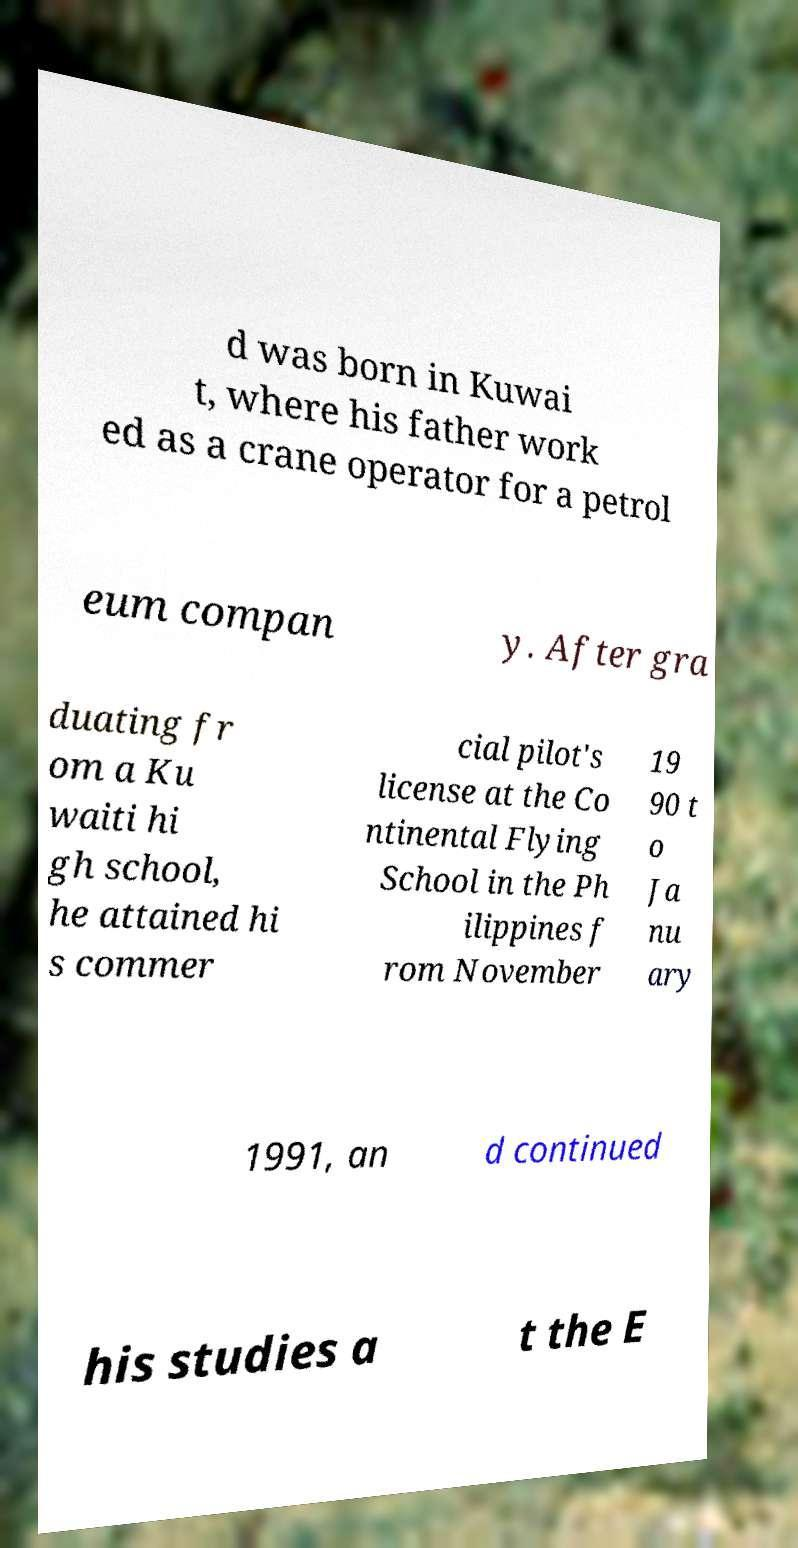What messages or text are displayed in this image? I need them in a readable, typed format. d was born in Kuwai t, where his father work ed as a crane operator for a petrol eum compan y. After gra duating fr om a Ku waiti hi gh school, he attained hi s commer cial pilot's license at the Co ntinental Flying School in the Ph ilippines f rom November 19 90 t o Ja nu ary 1991, an d continued his studies a t the E 